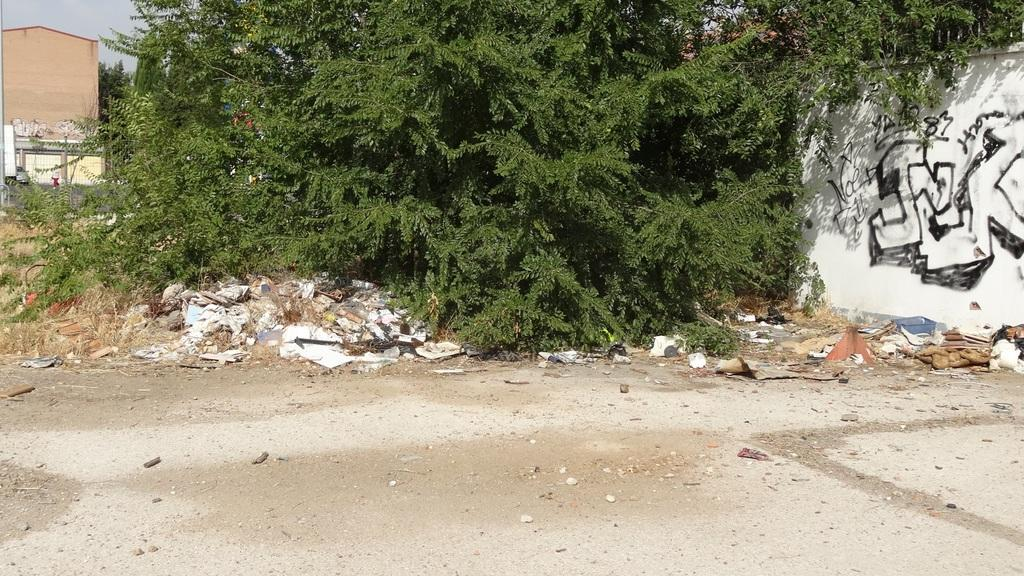What type of tree is in the image? There is a green tree in the image. What color is the wall in the image? There is a white color wall in the image. What part of the natural environment is visible in the image? The sky is visible in the image. What type of stone is being used to build the tree in the image? There is no stone being used to build the tree in the image; it is a natural tree. 